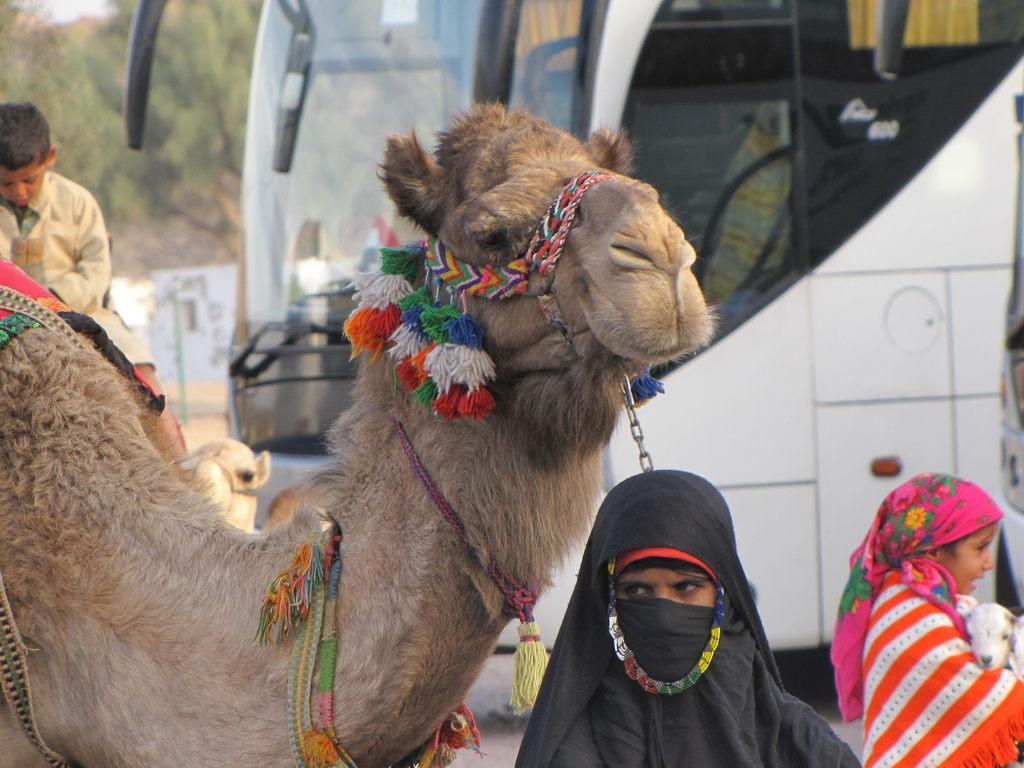What types of living organisms can be seen in the image? People and camels are visible in the image. What mode of transportation is present in the image? There is a bus in the image. What can be seen in the background of the image? Trees are visible in the background of the image. Can you tell me how many lakes are visible in the image? There are no lakes visible in the image. What type of growth can be observed on the camels in the image? There is no specific growth observed on the camels in the image; they appear to be regular camels. 